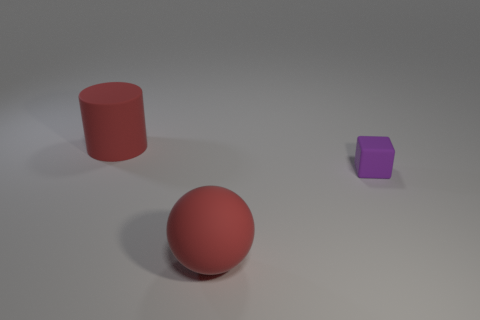The large matte object that is the same color as the ball is what shape?
Provide a succinct answer. Cylinder. How many purple things have the same size as the rubber block?
Offer a terse response. 0. Is the number of purple matte objects that are to the left of the rubber cylinder less than the number of small red rubber things?
Provide a short and direct response. No. How many balls are in front of the large cylinder?
Your response must be concise. 1. There is a red rubber thing that is to the left of the big thing that is in front of the large object that is to the left of the red rubber sphere; how big is it?
Provide a short and direct response. Large. The purple cube that is made of the same material as the red cylinder is what size?
Offer a very short reply. Small. Are there any other things of the same color as the matte cube?
Your response must be concise. No. What material is the red object right of the red rubber thing behind the big rubber object in front of the purple object?
Give a very brief answer. Rubber. What number of rubber things are red cylinders or tiny purple blocks?
Ensure brevity in your answer.  2. Is the color of the big cylinder the same as the large rubber ball?
Provide a short and direct response. Yes. 